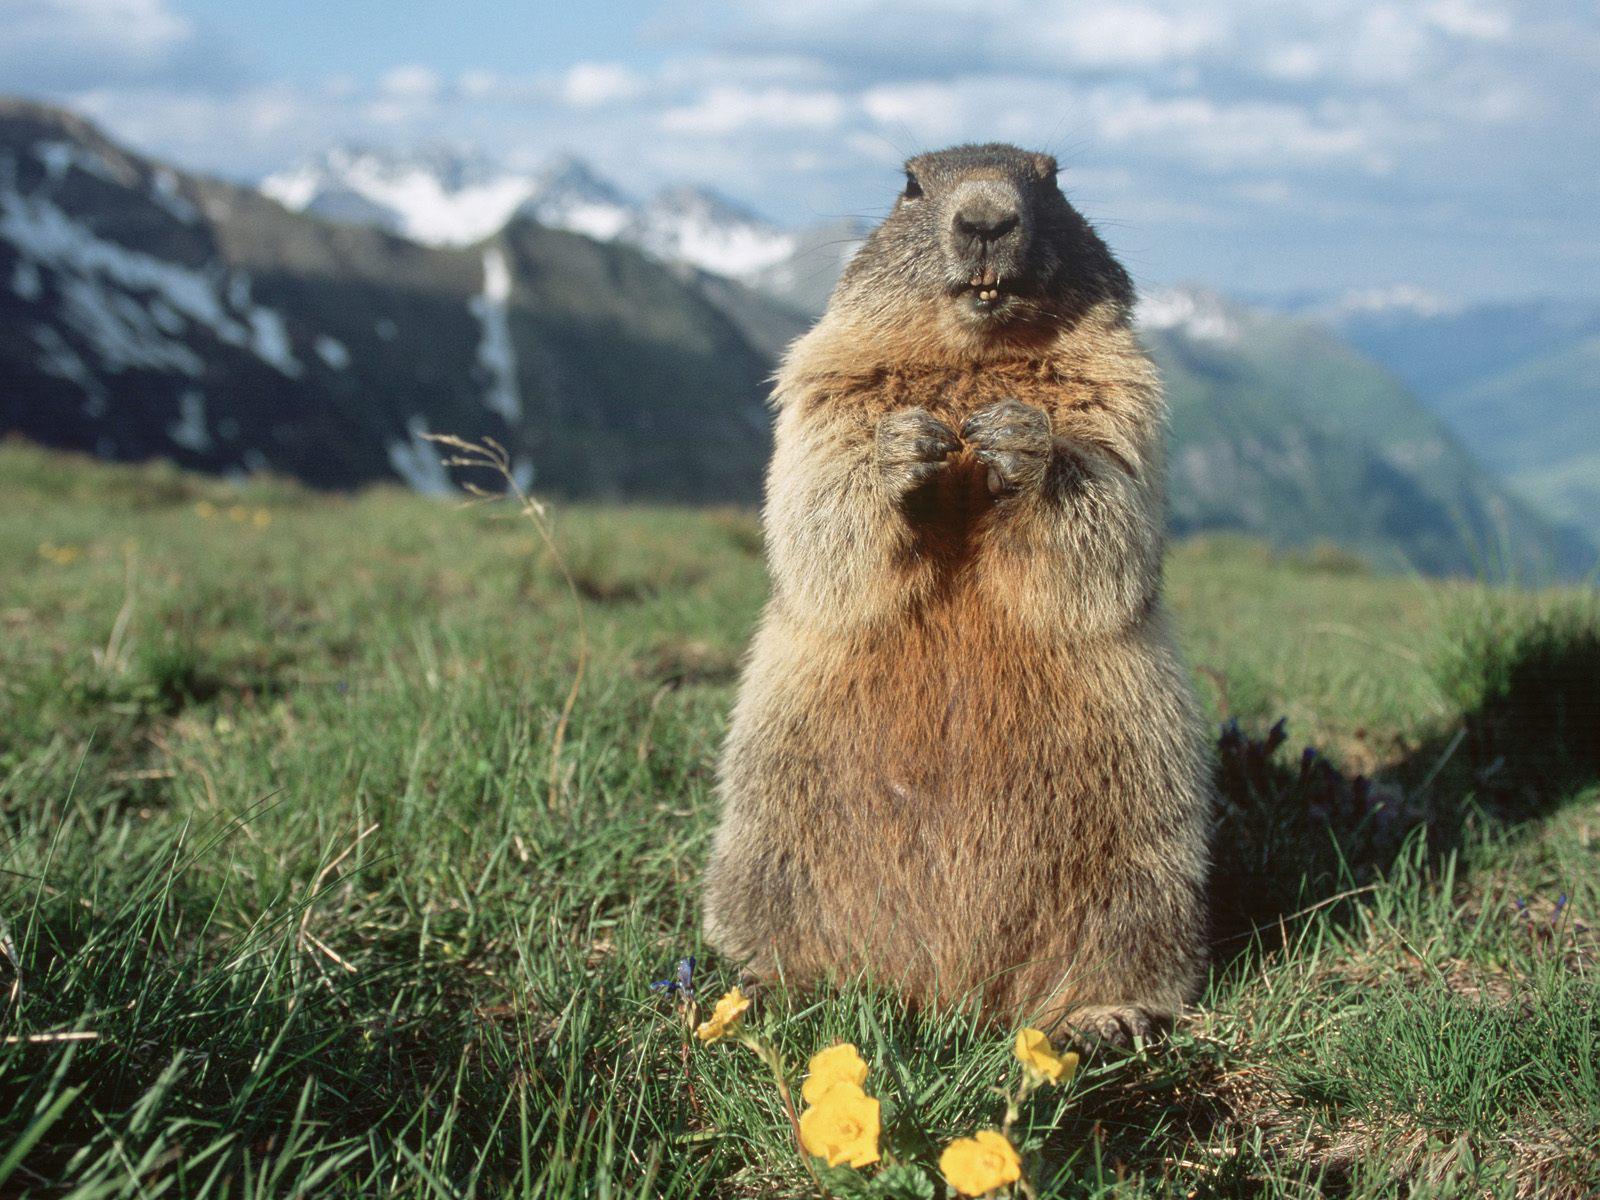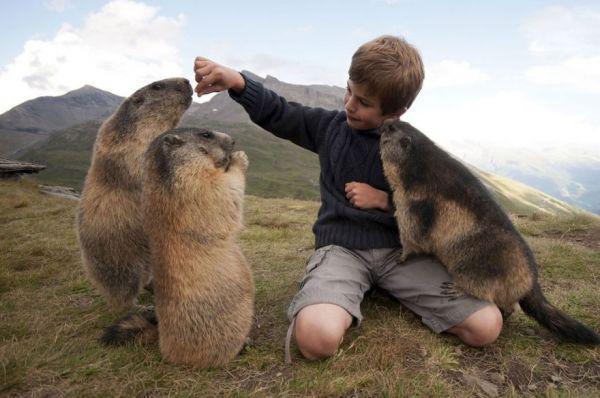The first image is the image on the left, the second image is the image on the right. Considering the images on both sides, is "A boy is kneeling on the ground as he plays with at least 3 groundhogs." valid? Answer yes or no. Yes. The first image is the image on the left, the second image is the image on the right. For the images displayed, is the sentence "In one image there is a lone marmot looking towards the camera." factually correct? Answer yes or no. Yes. 